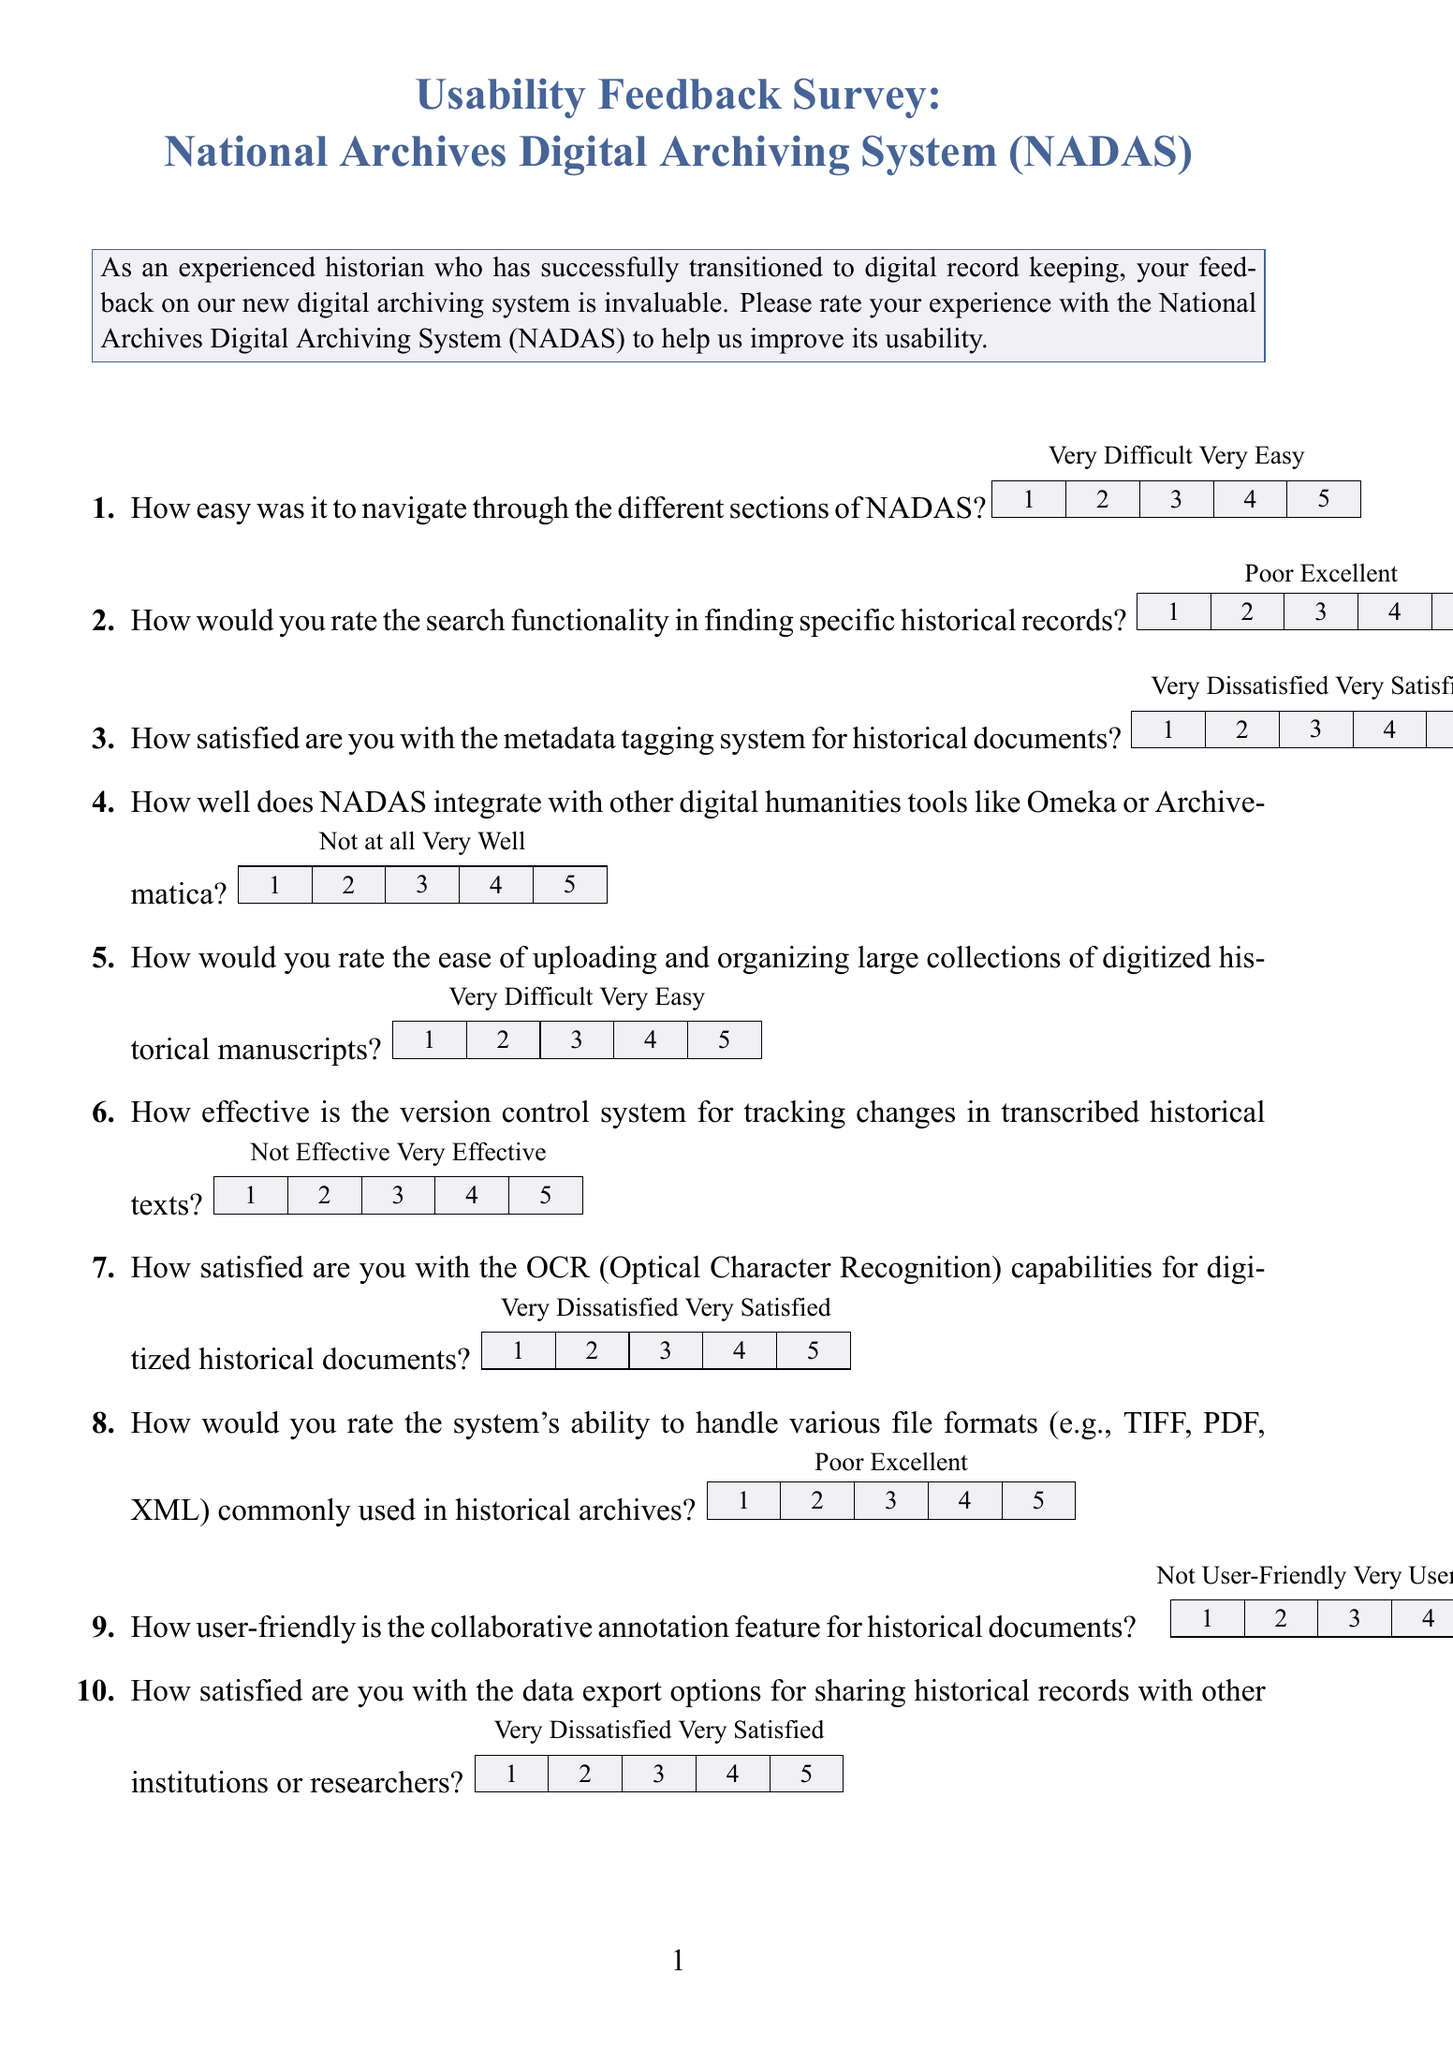What is the title of the survey? The title of the survey is typically stated prominently at the top of the document, which is "Usability Feedback Survey: National Archives Digital Archiving System (NADAS)."
Answer: Usability Feedback Survey: National Archives Digital Archiving System (NADAS) How many Likert scale questions are there? The total number of Likert scale questions can be counted from the enumerated list in the document, which has ten questions.
Answer: 10 What type of feedback is being collected in the survey? The survey's focus is indicated in the description, which states it's collecting feedback on the usability of NADAS.
Answer: Usability What is the purpose of the additional comments section? The purpose of the additional comments section is to gather further insights or suggestions from participants regarding their experience with NADAS.
Answer: Suggestions for improving NADAS What aspect does the question about searching functionality evaluate? The question evaluates the effectiveness and efficiency of the search feature in locating historical records within NADAS.
Answer: Search functionality How would you describe the visual elements used to represent the Likert scale? The visual elements are rectangles filled with color to indicate the rating scale with numbered options underneath.
Answer: Rectangles filled with color What rating options are available for the question on OCR capabilities? The rating options for the OCR capabilities question include five levels of satisfaction ranging from "Very Dissatisfied" to "Very Satisfied."
Answer: Very Dissatisfied to Very Satisfied How does the survey address integration with other tools? The survey includes a specific question targeting the integration of NADAS with other digital humanities tools to assess usability.
Answer: Integration with tools What are the various file formats mentioned in the survey? The survey specifically mentions TIFF, PDF, and XML as file formats commonly used in historical archives.
Answer: TIFF, PDF, XML How is the survey structured in terms of sections? The survey is structured into sections with clear questions that require ratings and a section for additional comments at the end.
Answer: Question and comments sections 